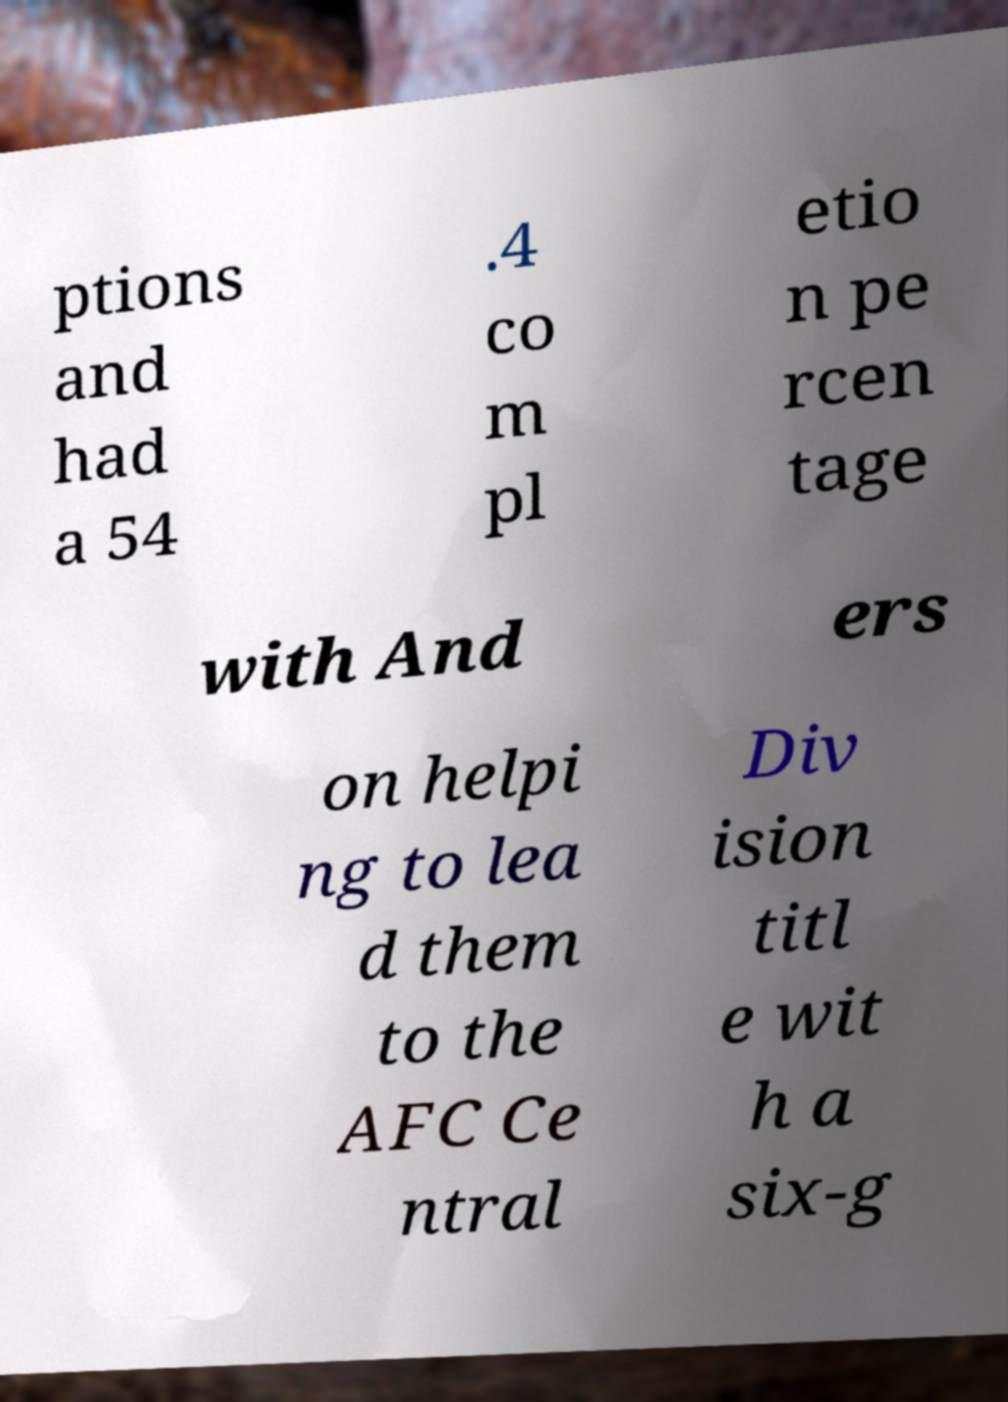Can you accurately transcribe the text from the provided image for me? ptions and had a 54 .4 co m pl etio n pe rcen tage with And ers on helpi ng to lea d them to the AFC Ce ntral Div ision titl e wit h a six-g 